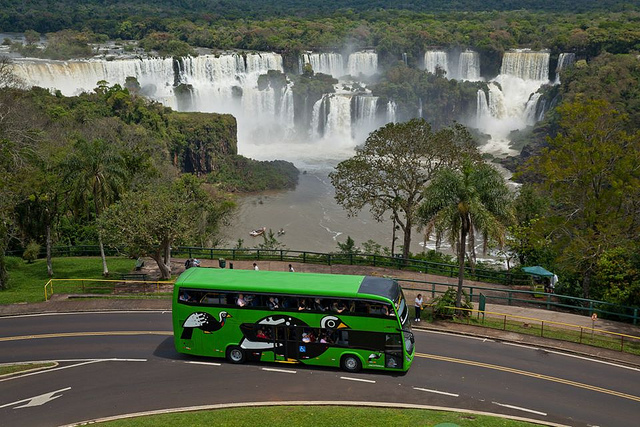<image>Where is the Grand Canyon? The Grand Canyon is not in the photo. However, it is usually located in Arizona. Where is the Grand Canyon? I don't know exactly where the Grand Canyon is located. It could be in Arizona or Nevada. 